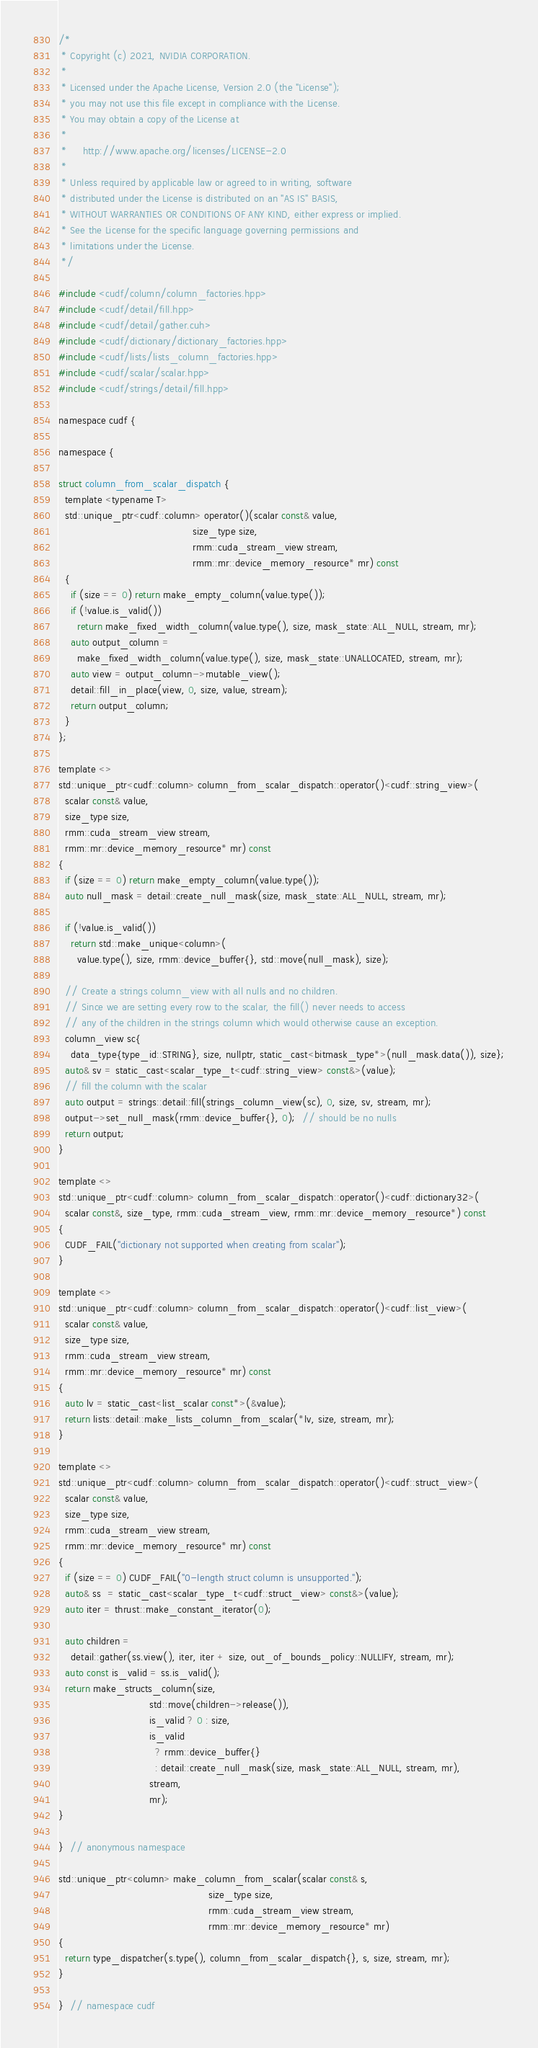Convert code to text. <code><loc_0><loc_0><loc_500><loc_500><_Cuda_>/*
 * Copyright (c) 2021, NVIDIA CORPORATION.
 *
 * Licensed under the Apache License, Version 2.0 (the "License");
 * you may not use this file except in compliance with the License.
 * You may obtain a copy of the License at
 *
 *     http://www.apache.org/licenses/LICENSE-2.0
 *
 * Unless required by applicable law or agreed to in writing, software
 * distributed under the License is distributed on an "AS IS" BASIS,
 * WITHOUT WARRANTIES OR CONDITIONS OF ANY KIND, either express or implied.
 * See the License for the specific language governing permissions and
 * limitations under the License.
 */

#include <cudf/column/column_factories.hpp>
#include <cudf/detail/fill.hpp>
#include <cudf/detail/gather.cuh>
#include <cudf/dictionary/dictionary_factories.hpp>
#include <cudf/lists/lists_column_factories.hpp>
#include <cudf/scalar/scalar.hpp>
#include <cudf/strings/detail/fill.hpp>

namespace cudf {

namespace {

struct column_from_scalar_dispatch {
  template <typename T>
  std::unique_ptr<cudf::column> operator()(scalar const& value,
                                           size_type size,
                                           rmm::cuda_stream_view stream,
                                           rmm::mr::device_memory_resource* mr) const
  {
    if (size == 0) return make_empty_column(value.type());
    if (!value.is_valid())
      return make_fixed_width_column(value.type(), size, mask_state::ALL_NULL, stream, mr);
    auto output_column =
      make_fixed_width_column(value.type(), size, mask_state::UNALLOCATED, stream, mr);
    auto view = output_column->mutable_view();
    detail::fill_in_place(view, 0, size, value, stream);
    return output_column;
  }
};

template <>
std::unique_ptr<cudf::column> column_from_scalar_dispatch::operator()<cudf::string_view>(
  scalar const& value,
  size_type size,
  rmm::cuda_stream_view stream,
  rmm::mr::device_memory_resource* mr) const
{
  if (size == 0) return make_empty_column(value.type());
  auto null_mask = detail::create_null_mask(size, mask_state::ALL_NULL, stream, mr);

  if (!value.is_valid())
    return std::make_unique<column>(
      value.type(), size, rmm::device_buffer{}, std::move(null_mask), size);

  // Create a strings column_view with all nulls and no children.
  // Since we are setting every row to the scalar, the fill() never needs to access
  // any of the children in the strings column which would otherwise cause an exception.
  column_view sc{
    data_type{type_id::STRING}, size, nullptr, static_cast<bitmask_type*>(null_mask.data()), size};
  auto& sv = static_cast<scalar_type_t<cudf::string_view> const&>(value);
  // fill the column with the scalar
  auto output = strings::detail::fill(strings_column_view(sc), 0, size, sv, stream, mr);
  output->set_null_mask(rmm::device_buffer{}, 0);  // should be no nulls
  return output;
}

template <>
std::unique_ptr<cudf::column> column_from_scalar_dispatch::operator()<cudf::dictionary32>(
  scalar const&, size_type, rmm::cuda_stream_view, rmm::mr::device_memory_resource*) const
{
  CUDF_FAIL("dictionary not supported when creating from scalar");
}

template <>
std::unique_ptr<cudf::column> column_from_scalar_dispatch::operator()<cudf::list_view>(
  scalar const& value,
  size_type size,
  rmm::cuda_stream_view stream,
  rmm::mr::device_memory_resource* mr) const
{
  auto lv = static_cast<list_scalar const*>(&value);
  return lists::detail::make_lists_column_from_scalar(*lv, size, stream, mr);
}

template <>
std::unique_ptr<cudf::column> column_from_scalar_dispatch::operator()<cudf::struct_view>(
  scalar const& value,
  size_type size,
  rmm::cuda_stream_view stream,
  rmm::mr::device_memory_resource* mr) const
{
  if (size == 0) CUDF_FAIL("0-length struct column is unsupported.");
  auto& ss  = static_cast<scalar_type_t<cudf::struct_view> const&>(value);
  auto iter = thrust::make_constant_iterator(0);

  auto children =
    detail::gather(ss.view(), iter, iter + size, out_of_bounds_policy::NULLIFY, stream, mr);
  auto const is_valid = ss.is_valid();
  return make_structs_column(size,
                             std::move(children->release()),
                             is_valid ? 0 : size,
                             is_valid
                               ? rmm::device_buffer{}
                               : detail::create_null_mask(size, mask_state::ALL_NULL, stream, mr),
                             stream,
                             mr);
}

}  // anonymous namespace

std::unique_ptr<column> make_column_from_scalar(scalar const& s,
                                                size_type size,
                                                rmm::cuda_stream_view stream,
                                                rmm::mr::device_memory_resource* mr)
{
  return type_dispatcher(s.type(), column_from_scalar_dispatch{}, s, size, stream, mr);
}

}  // namespace cudf
</code> 